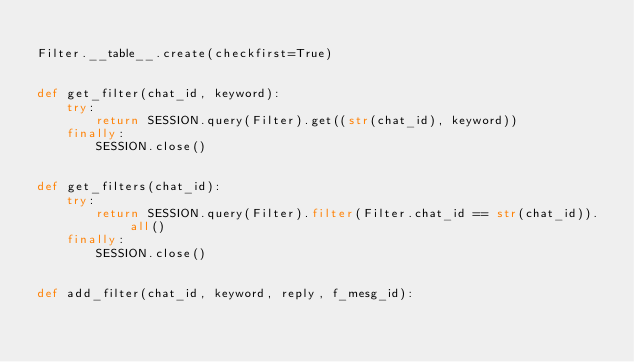<code> <loc_0><loc_0><loc_500><loc_500><_Python_>
Filter.__table__.create(checkfirst=True)


def get_filter(chat_id, keyword):
    try:
        return SESSION.query(Filter).get((str(chat_id), keyword))
    finally:
        SESSION.close()


def get_filters(chat_id):
    try:
        return SESSION.query(Filter).filter(Filter.chat_id == str(chat_id)).all()
    finally:
        SESSION.close()


def add_filter(chat_id, keyword, reply, f_mesg_id):</code> 